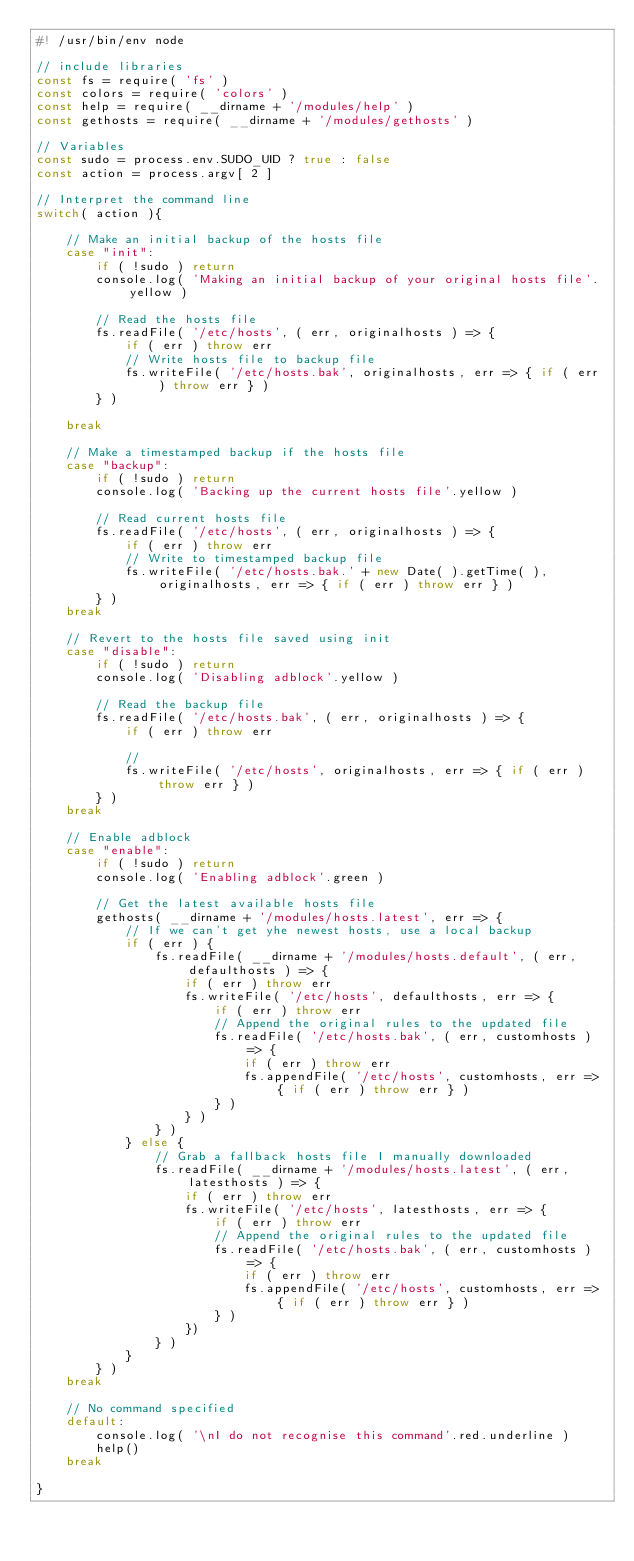<code> <loc_0><loc_0><loc_500><loc_500><_JavaScript_>#! /usr/bin/env node

// include libraries
const fs = require( 'fs' )
const colors = require( 'colors' )
const help = require( __dirname + '/modules/help' )
const gethosts = require( __dirname + '/modules/gethosts' )

// Variables
const sudo = process.env.SUDO_UID ? true : false
const action = process.argv[ 2 ]

// Interpret the command line
switch( action ){ 

	// Make an initial backup of the hosts file
	case "init":
		if ( !sudo ) return
		console.log( 'Making an initial backup of your original hosts file'.yellow )

		// Read the hosts file
		fs.readFile( '/etc/hosts', ( err, originalhosts ) => {
			if ( err ) throw err
			// Write hosts file to backup file
			fs.writeFile( '/etc/hosts.bak', originalhosts, err => { if ( err ) throw err } )
		} )

	break

	// Make a timestamped backup if the hosts file
	case "backup":
		if ( !sudo ) return
		console.log( 'Backing up the current hosts file'.yellow )

		// Read current hosts file
		fs.readFile( '/etc/hosts', ( err, originalhosts ) => {
			if ( err ) throw err
			// Write to timestamped backup file
			fs.writeFile( '/etc/hosts.bak.' + new Date( ).getTime( ), originalhosts, err => { if ( err ) throw err } )
		} )
	break

	// Revert to the hosts file saved using init
	case "disable":
		if ( !sudo ) return
		console.log( 'Disabling adblock'.yellow )

		// Read the backup file
		fs.readFile( '/etc/hosts.bak', ( err, originalhosts ) => {
			if ( err ) throw err

			// 
			fs.writeFile( '/etc/hosts', originalhosts, err => { if ( err ) throw err } )
		} )
	break

	// Enable adblock
	case "enable":
		if ( !sudo ) return
		console.log( 'Enabling adblock'.green )

		// Get the latest available hosts file
		gethosts( __dirname + '/modules/hosts.latest', err => {
			// If we can't get yhe newest hosts, use a local backup
			if ( err ) {
				fs.readFile( __dirname + '/modules/hosts.default', ( err, defaulthosts ) => {
					if ( err ) throw err
					fs.writeFile( '/etc/hosts', defaulthosts, err => { 
						if ( err ) throw err
						// Append the original rules to the updated file
						fs.readFile( '/etc/hosts.bak', ( err, customhosts ) => {
							if ( err ) throw err
							fs.appendFile( '/etc/hosts', customhosts, err => { if ( err ) throw err } )
						} )
					} )
				} )
			} else {
				// Grab a fallback hosts file I manually downloaded
				fs.readFile( __dirname + '/modules/hosts.latest', ( err, latesthosts ) => {
					if ( err ) throw err
					fs.writeFile( '/etc/hosts', latesthosts, err => {
						if ( err ) throw err
						// Append the original rules to the updated file
						fs.readFile( '/etc/hosts.bak', ( err, customhosts ) => {
							if ( err ) throw err
							fs.appendFile( '/etc/hosts', customhosts, err => { if ( err ) throw err } )
						} )
					})
				} )
			}
		} )
	break

	// No command specified
	default:
		console.log( '\nI do not recognise this command'.red.underline )
		help()
	break

}</code> 